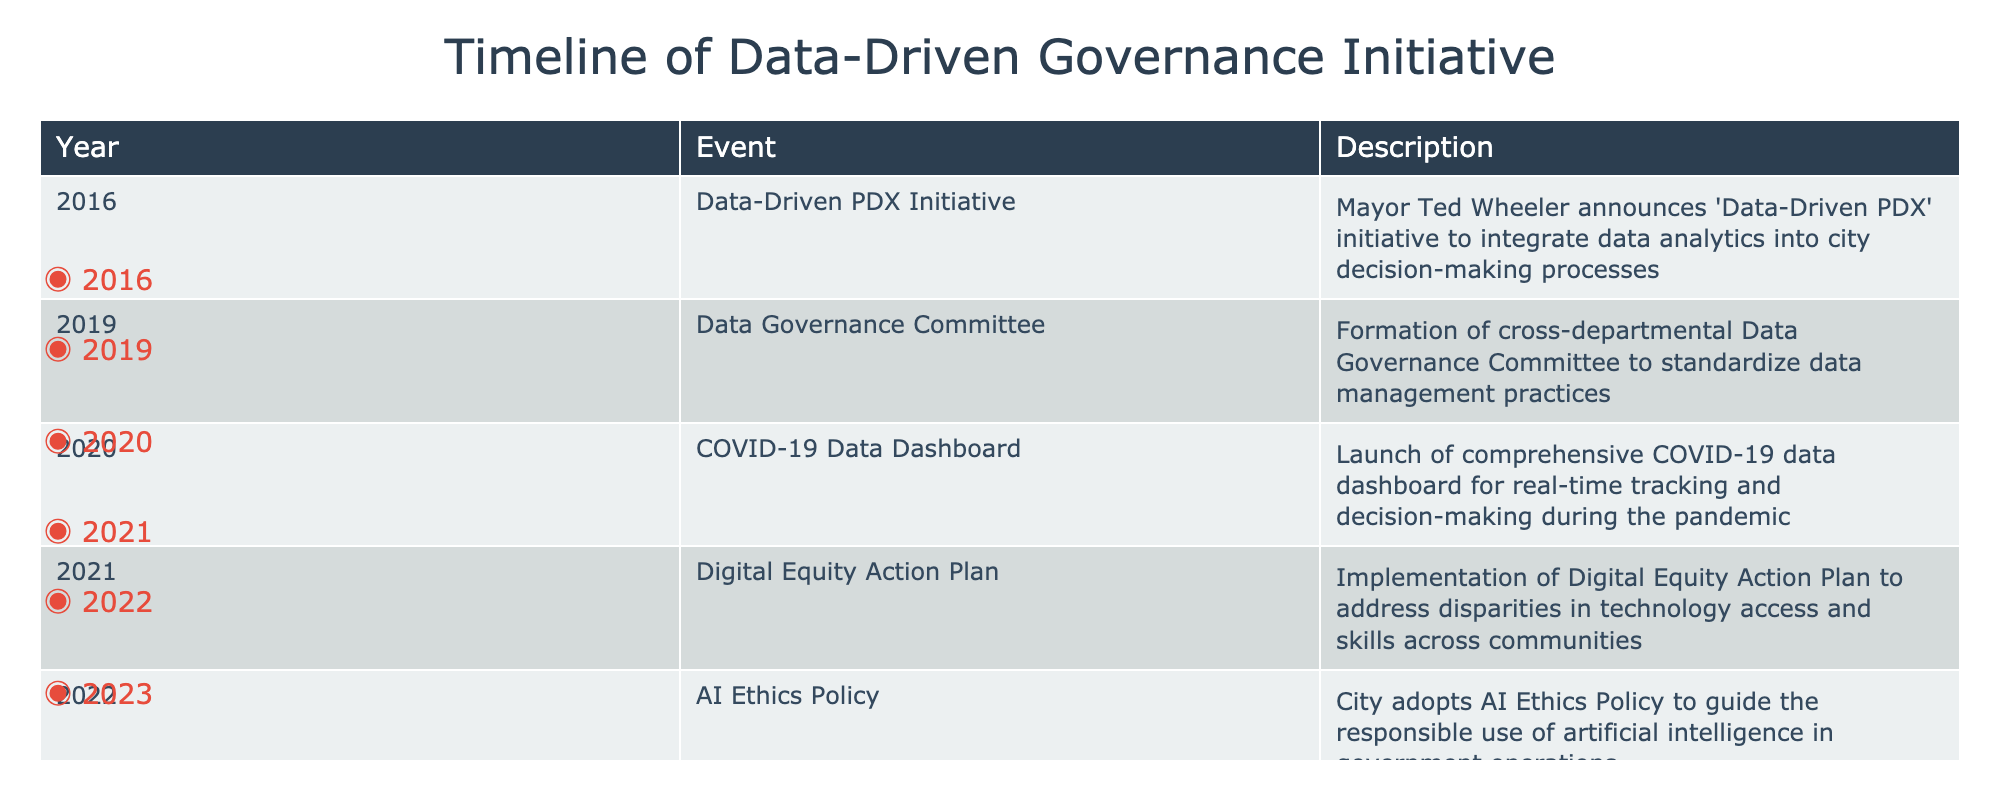What year was the Data-Driven PDX Initiative announced? The table indicates that the Data-Driven PDX Initiative was announced in 2016, as listed in the 'Year' column for that event.
Answer: 2016 How many events occurred in 2020? According to the table, there is one event listed for 2020, which is the launch of the COVID-19 Data Dashboard.
Answer: 1 What is the year range of the events listed? The table lists events from 2016 to 2023, representing the earliest and latest events. The difference between these years indicates the range.
Answer: 2016 to 2023 Did the city adopt an AI Ethics Policy before the implementation of the Digital Equity Action Plan? By comparing the years in the table, the AI Ethics Policy was adopted in 2022, while the Digital Equity Action Plan was implemented in 2021, making this statement false.
Answer: No How many years were there between the announcement of the Data-Driven PDX Initiative and the introduction of the Community Data Fellows Program? The Data-Driven PDX Initiative was announced in 2016, and the Community Data Fellows Program was introduced in 2023. The difference in years is 2023 - 2016 = 7 years.
Answer: 7 years Which event involved the formation of a committee, and what year did it occur? The Data Governance Committee was formed in 2019, as stated in the 'Event' and 'Year' columns of the table.
Answer: Data Governance Committee, 2019 What was the last event listed, and what was its main focus? The last event in the table is the introduction of the Community Data Fellows Program in 2023, focused on training local activists in data analysis and advocacy.
Answer: Community Data Fellows Program, training local activists How many events focus specifically on technology and data ethics? The table lists two events specifically focusing on technology and ethics: the Digital Equity Action Plan (2021) and AI Ethics Policy (2022). Therefore, the total is two.
Answer: 2 